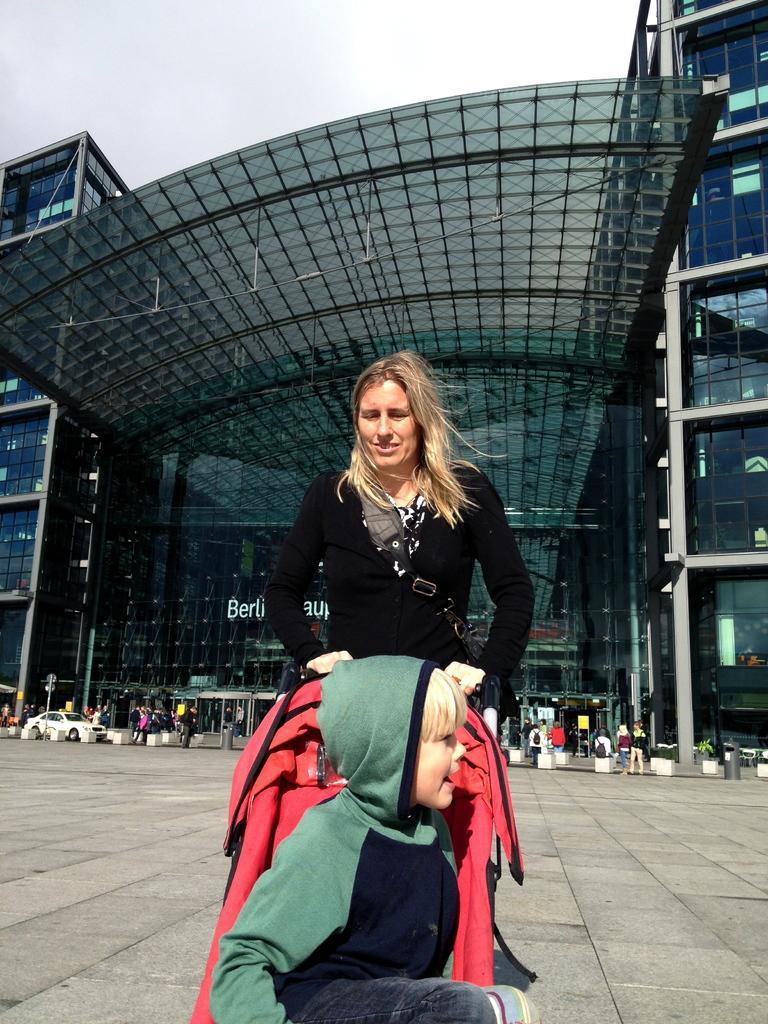Please provide a concise description of this image. In the foreground of this image, there is a boy at the bottom in a baby cart and it is holding by a woman. In the background, there is a building, a vehicle and the people are standing and walking. At the top, there is the sky. 